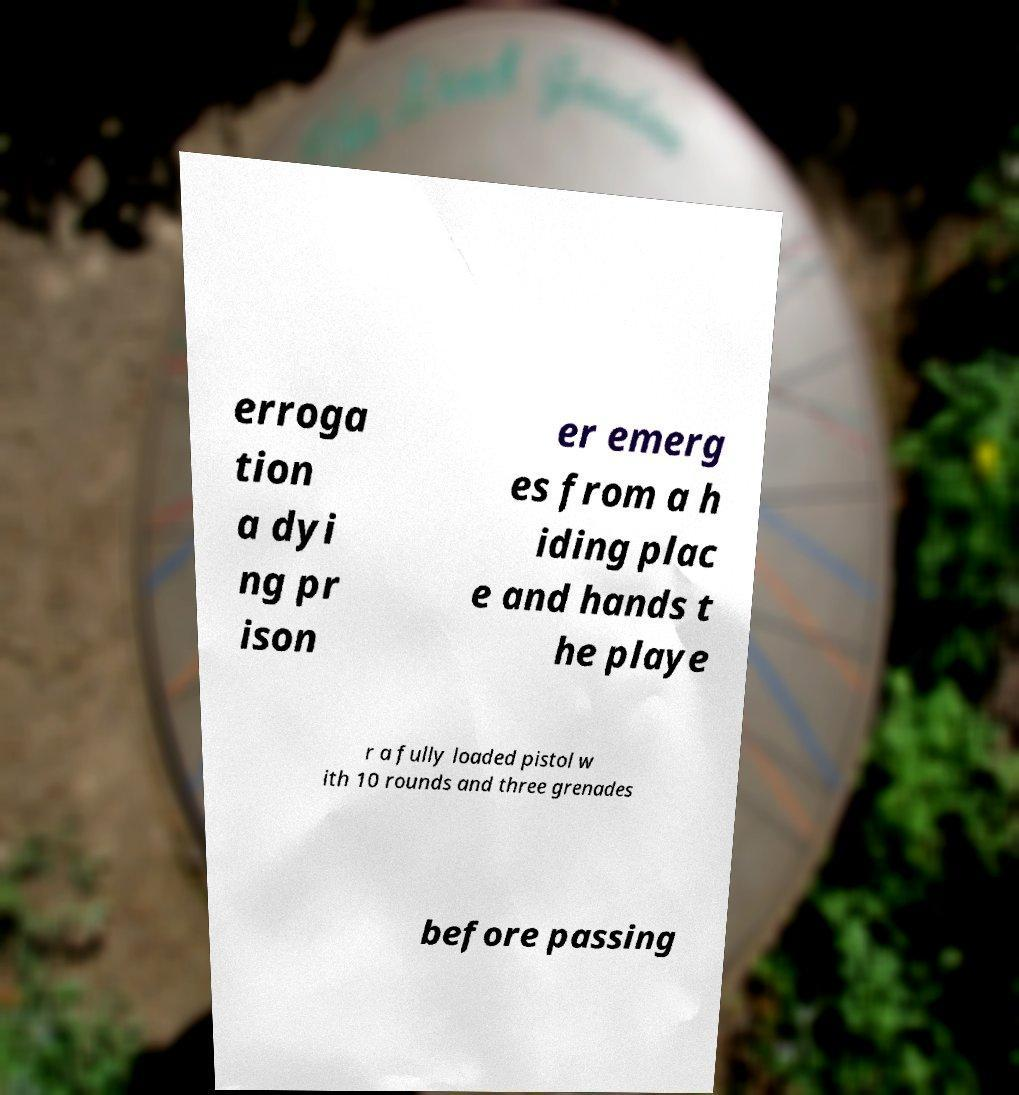Could you assist in decoding the text presented in this image and type it out clearly? erroga tion a dyi ng pr ison er emerg es from a h iding plac e and hands t he playe r a fully loaded pistol w ith 10 rounds and three grenades before passing 